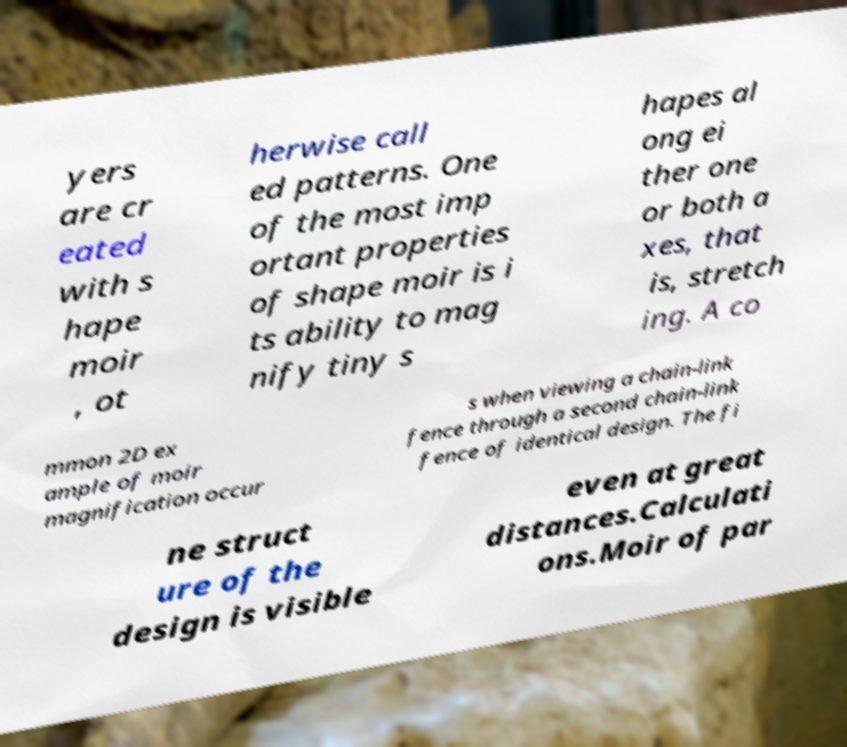I need the written content from this picture converted into text. Can you do that? yers are cr eated with s hape moir , ot herwise call ed patterns. One of the most imp ortant properties of shape moir is i ts ability to mag nify tiny s hapes al ong ei ther one or both a xes, that is, stretch ing. A co mmon 2D ex ample of moir magnification occur s when viewing a chain-link fence through a second chain-link fence of identical design. The fi ne struct ure of the design is visible even at great distances.Calculati ons.Moir of par 